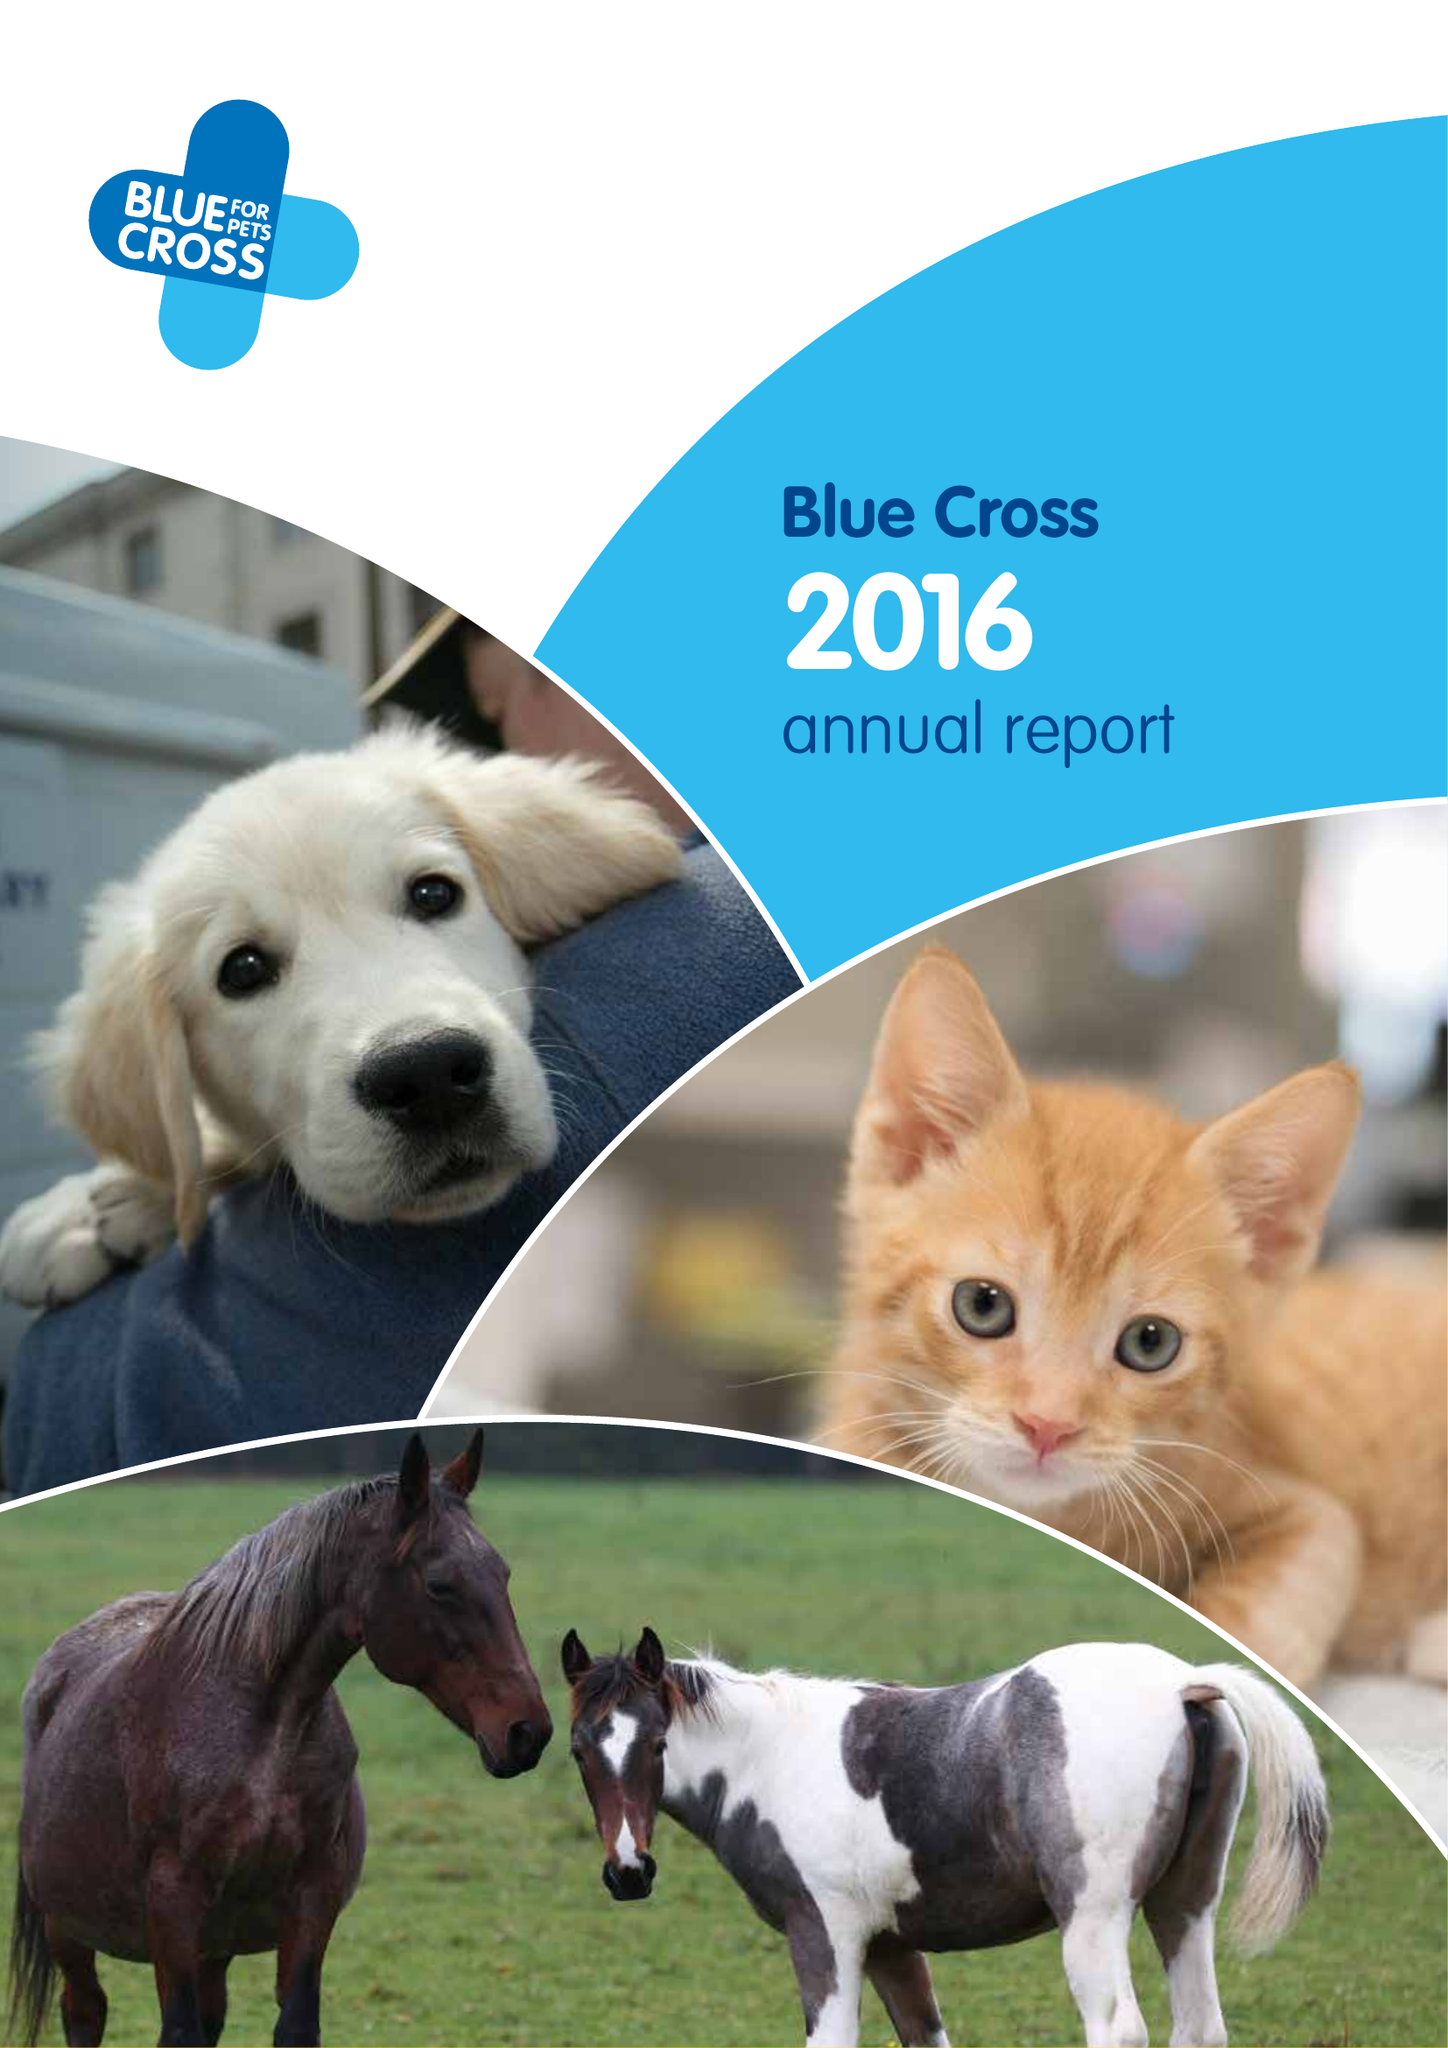What is the value for the address__post_town?
Answer the question using a single word or phrase. BURFORD 